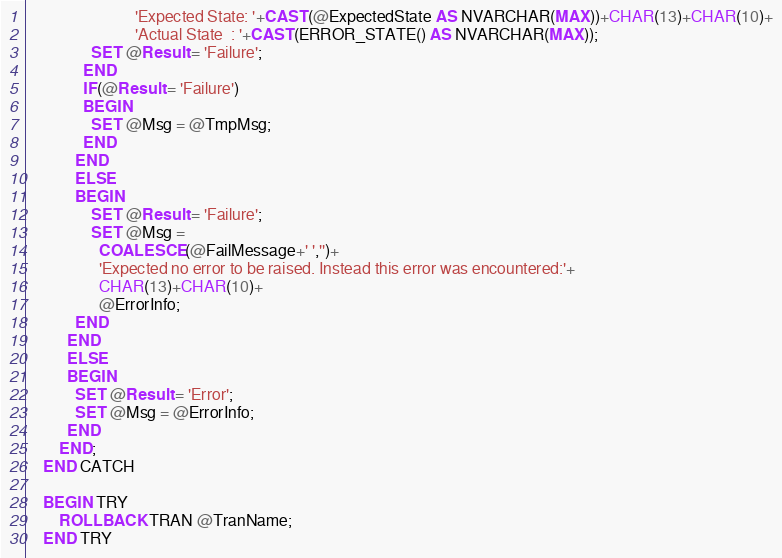Convert code to text. <code><loc_0><loc_0><loc_500><loc_500><_SQL_>                           'Expected State: '+CAST(@ExpectedState AS NVARCHAR(MAX))+CHAR(13)+CHAR(10)+
                           'Actual State  : '+CAST(ERROR_STATE() AS NVARCHAR(MAX));
                SET @Result = 'Failure';
              END
              IF(@Result = 'Failure')
              BEGIN
                SET @Msg = @TmpMsg;
              END
            END 
            ELSE
            BEGIN
                SET @Result = 'Failure';
                SET @Msg = 
                  COALESCE(@FailMessage+' ','')+
                  'Expected no error to be raised. Instead this error was encountered:'+
                  CHAR(13)+CHAR(10)+
                  @ErrorInfo;
            END
          END
          ELSE
          BEGIN
            SET @Result = 'Error';
            SET @Msg = @ErrorInfo;
          END  
        END;
    END CATCH

    BEGIN TRY
        ROLLBACK TRAN @TranName;
    END TRY</code> 